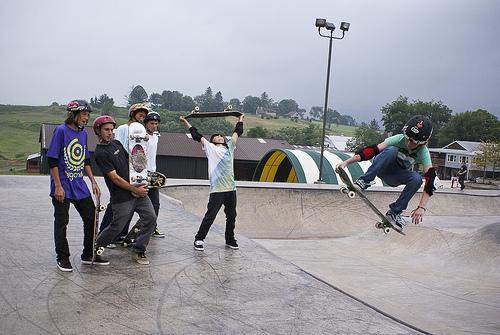What are the people doing?
Answer briefly. Skateboarding. Is it a sunny day?
Write a very short answer. No. How many people are wearing a yellow shirt?
Give a very brief answer. 0. Are they celebrating something?
Concise answer only. Yes. How many umbrellas do you see?
Keep it brief. 0. What caused the marks on the concrete in this photograph?
Be succinct. Skateboards. What surface are the children playing on?
Write a very short answer. Concrete. What activity is taking place in this scene?
Answer briefly. Skateboarding. Is this  a beach?
Give a very brief answer. No. Is it raining?
Answer briefly. Yes. Is the guy skateboarding wearing protective gear?
Give a very brief answer. Yes. What does the man in the blue shirt have in his hand?
Be succinct. Skateboard. 